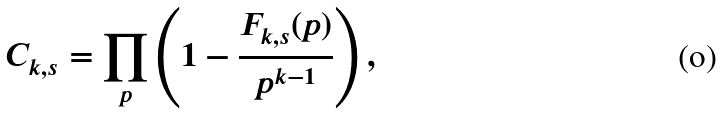Convert formula to latex. <formula><loc_0><loc_0><loc_500><loc_500>C _ { k , s } = \prod _ { p } \left ( 1 - \frac { F _ { k , s } ( p ) } { p ^ { k - 1 } } \right ) ,</formula> 